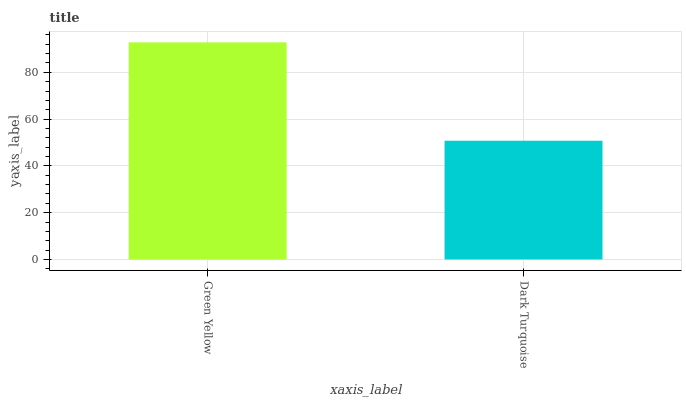Is Dark Turquoise the minimum?
Answer yes or no. Yes. Is Green Yellow the maximum?
Answer yes or no. Yes. Is Dark Turquoise the maximum?
Answer yes or no. No. Is Green Yellow greater than Dark Turquoise?
Answer yes or no. Yes. Is Dark Turquoise less than Green Yellow?
Answer yes or no. Yes. Is Dark Turquoise greater than Green Yellow?
Answer yes or no. No. Is Green Yellow less than Dark Turquoise?
Answer yes or no. No. Is Green Yellow the high median?
Answer yes or no. Yes. Is Dark Turquoise the low median?
Answer yes or no. Yes. Is Dark Turquoise the high median?
Answer yes or no. No. Is Green Yellow the low median?
Answer yes or no. No. 